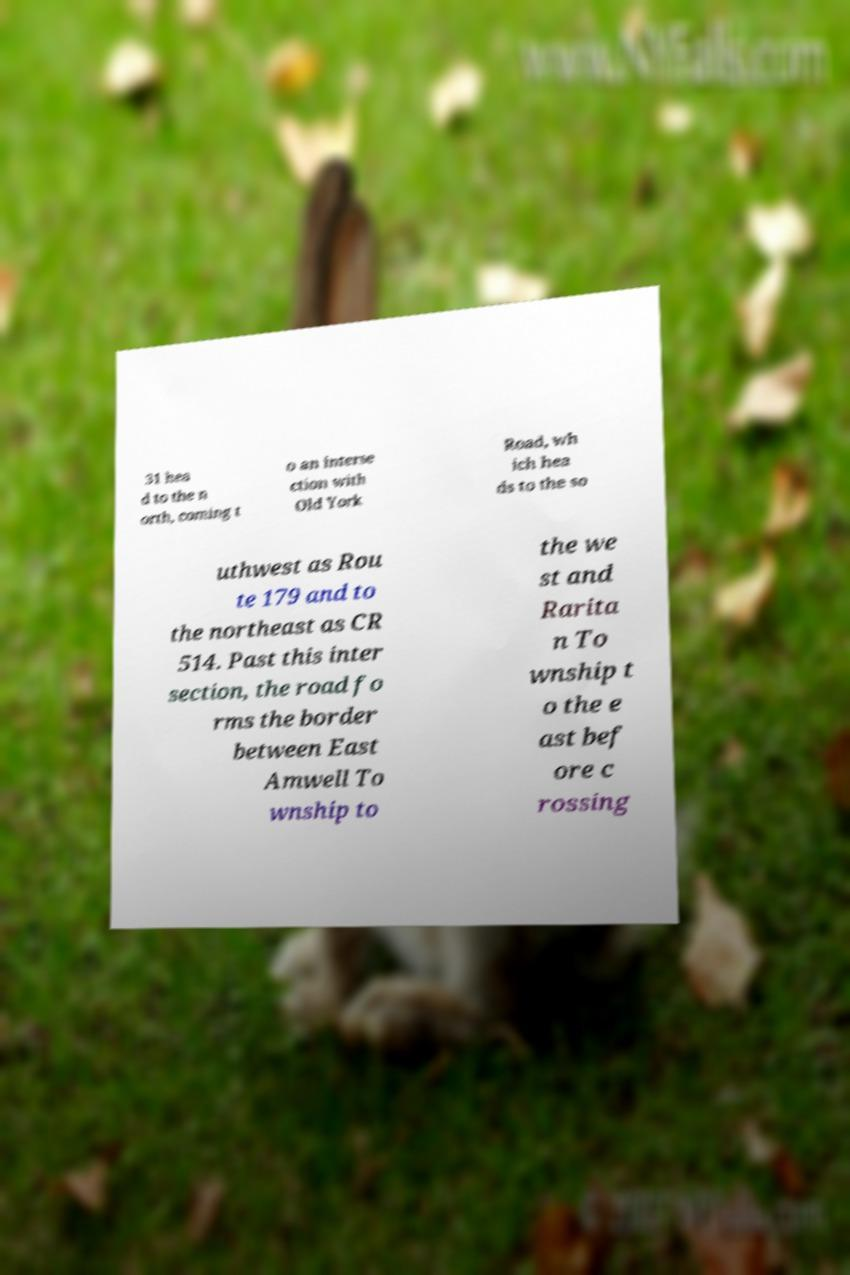Could you extract and type out the text from this image? 31 hea d to the n orth, coming t o an interse ction with Old York Road, wh ich hea ds to the so uthwest as Rou te 179 and to the northeast as CR 514. Past this inter section, the road fo rms the border between East Amwell To wnship to the we st and Rarita n To wnship t o the e ast bef ore c rossing 